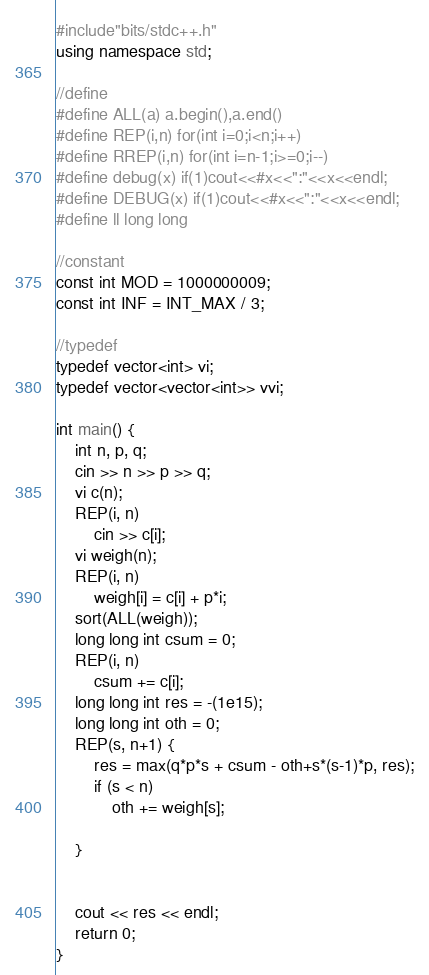<code> <loc_0><loc_0><loc_500><loc_500><_C++_>#include"bits/stdc++.h"
using namespace std;

//define
#define ALL(a) a.begin(),a.end()
#define REP(i,n) for(int i=0;i<n;i++)
#define RREP(i,n) for(int i=n-1;i>=0;i--)
#define debug(x) if(1)cout<<#x<<":"<<x<<endl;
#define DEBUG(x) if(1)cout<<#x<<":"<<x<<endl;
#define ll long long

//constant
const int MOD = 1000000009;
const int INF = INT_MAX / 3;

//typedef
typedef vector<int> vi;
typedef vector<vector<int>> vvi;

int main() {
	int n, p, q;
	cin >> n >> p >> q;
	vi c(n);
	REP(i, n)
		cin >> c[i];
	vi weigh(n);
	REP(i, n)
		weigh[i] = c[i] + p*i;
	sort(ALL(weigh));
	long long int csum = 0;
	REP(i, n)
		csum += c[i];
	long long int res = -(1e15);
	long long int oth = 0;
	REP(s, n+1) {
		res = max(q*p*s + csum - oth+s*(s-1)*p, res);
		if (s < n)
			oth += weigh[s];

	}


	cout << res << endl;
	return 0;
}</code> 